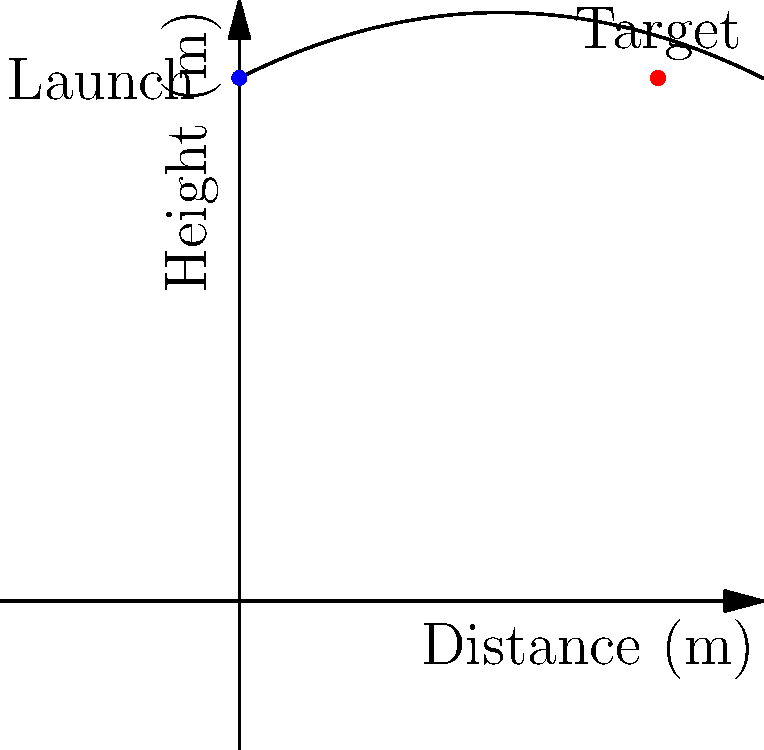A charitable organization plans to use a catapult to launch essential supplies to a community in need located 8 meters away. If the catapult launches the supplies from a height of 10 meters, what initial velocity (in m/s) should be given to the supplies to reach the target, assuming no air resistance and neglecting the size of the package? To solve this problem, we'll use the equations of projectile motion:

1) Horizontal motion: $x = v_0 \cos(\theta) t$
2) Vertical motion: $y = h_0 + v_0 \sin(\theta) t - \frac{1}{2}gt^2$

Where:
- $x$ is the horizontal distance (8 m)
- $y$ is the vertical position (0 m at the target)
- $h_0$ is the initial height (10 m)
- $v_0$ is the initial velocity (what we're solving for)
- $\theta$ is the launch angle (45° for maximum range)
- $g$ is the acceleration due to gravity (9.8 m/s²)
- $t$ is the time of flight

Steps:
1) From the horizontal motion equation, we can find $t$:
   $8 = v_0 \cos(45°) t$
   $t = \frac{8}{v_0 \cos(45°)}$

2) Substitute this into the vertical motion equation:
   $0 = 10 + v_0 \sin(45°) (\frac{8}{v_0 \cos(45°)}) - \frac{1}{2}g(\frac{8}{v_0 \cos(45°)})^2$

3) Simplify, noting that $\sin(45°) = \cos(45°) = \frac{1}{\sqrt{2}}$:
   $0 = 10 + 8 - \frac{1}{2}g(\frac{8\sqrt{2}}{v_0})^2$

4) Solve for $v_0$:
   $\frac{1}{2}g(\frac{8\sqrt{2}}{v_0})^2 = 18$
   $v_0^2 = \frac{1}{2}g(8\sqrt{2})^2 / 18$
   $v_0 = \sqrt{\frac{g(8\sqrt{2})^2}{36}} \approx 8.85$ m/s

Therefore, the initial velocity should be approximately 8.85 m/s.
Answer: 8.85 m/s 